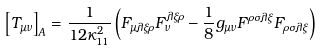<formula> <loc_0><loc_0><loc_500><loc_500>\left [ T _ { \mu \nu } \right ] _ { A } = \frac { 1 } { 1 2 \kappa _ { 1 1 } ^ { 2 } } \left ( F _ { \mu \lambda \xi \rho } F _ { \nu } ^ { \lambda \xi \rho } - \frac { 1 } { 8 } g _ { \mu \nu } F ^ { \rho \sigma \lambda \xi } F _ { \rho \sigma \lambda \xi } \right )</formula> 